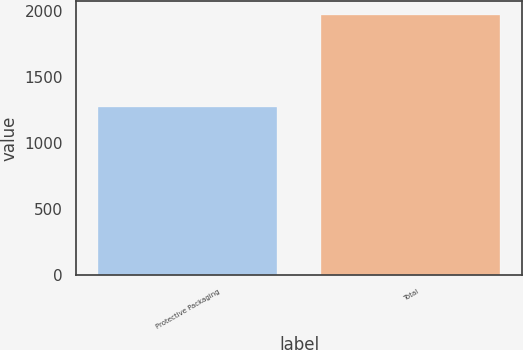Convert chart to OTSL. <chart><loc_0><loc_0><loc_500><loc_500><bar_chart><fcel>Protective Packaging<fcel>Total<nl><fcel>1275.2<fcel>1969.7<nl></chart> 